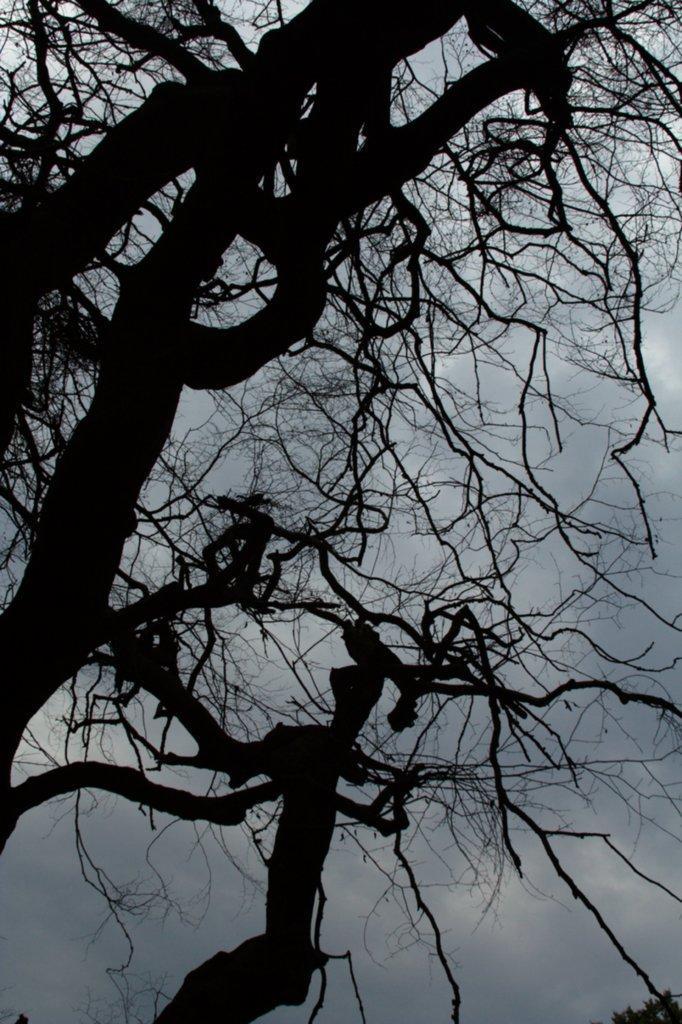Could you give a brief overview of what you see in this image? In the image in the center we can see sky,clouds and trees. 